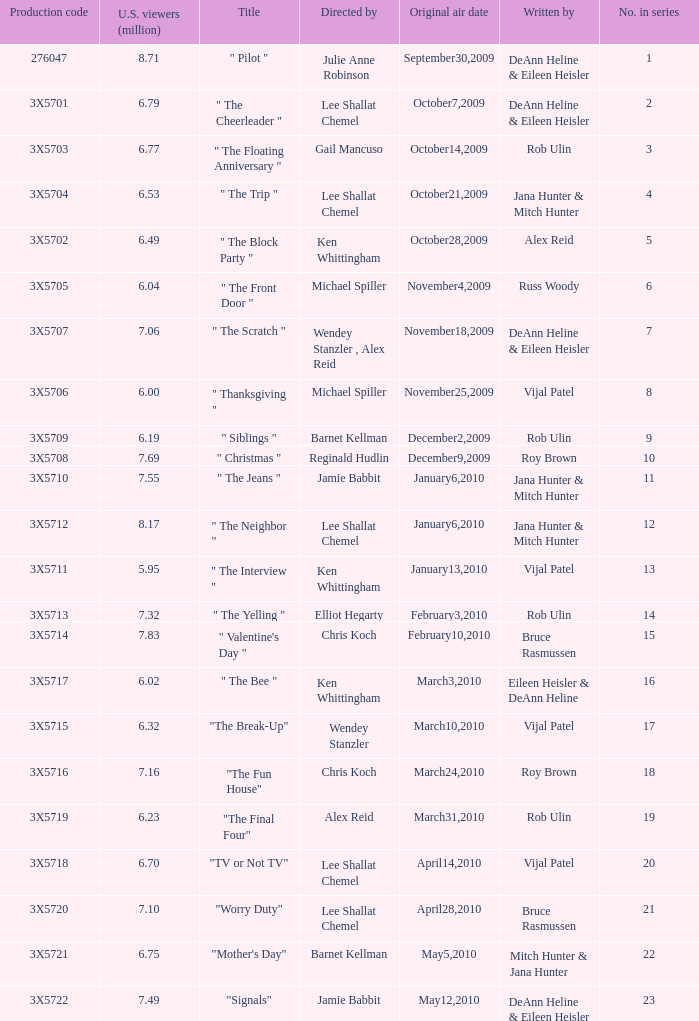How many million U.S. viewers saw the episode with production code 3X5710? 7.55. 